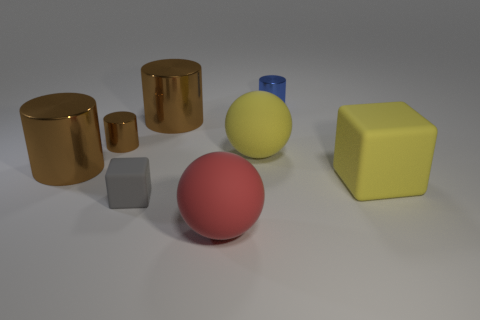Is the big brown thing that is behind the big yellow matte sphere made of the same material as the sphere that is in front of the large yellow sphere?
Your answer should be very brief. No. What is the tiny blue cylinder made of?
Keep it short and to the point. Metal. What number of yellow balls are made of the same material as the big cube?
Give a very brief answer. 1. What number of shiny things are either tiny things or small gray things?
Your answer should be very brief. 2. There is a rubber object to the right of the tiny blue metallic object; is it the same shape as the large yellow rubber thing on the left side of the small blue metal thing?
Make the answer very short. No. There is a large rubber thing that is both left of the small blue shiny object and behind the large red rubber sphere; what is its color?
Your answer should be very brief. Yellow. There is a matte object to the right of the blue metal cylinder; is its size the same as the matte thing to the left of the large red thing?
Make the answer very short. No. How many small cylinders have the same color as the tiny matte block?
Give a very brief answer. 0. What number of large objects are blue metal cylinders or gray matte objects?
Your answer should be compact. 0. Does the big cylinder that is on the left side of the gray matte thing have the same material as the blue thing?
Ensure brevity in your answer.  Yes. 